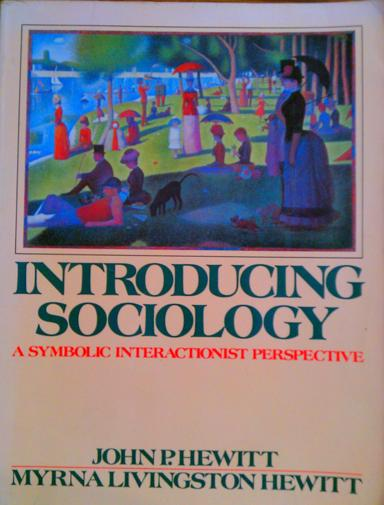Can you comment on the symbolism of the cover art used in 'Introducing Sociology: A Symbolic Interactionist Perspective'? The cover art, depicting a diverse group of people engaging in various activities in a park-like setting, symbolizes the core tenets of symbolic interactionism. Each individual is shown in a unique interaction, highlighting how personal actions and interactions contribute to the broader social fabric. The setting emphasizes community and collective activity, which are crucial aspects of societal structure studied in sociology. 